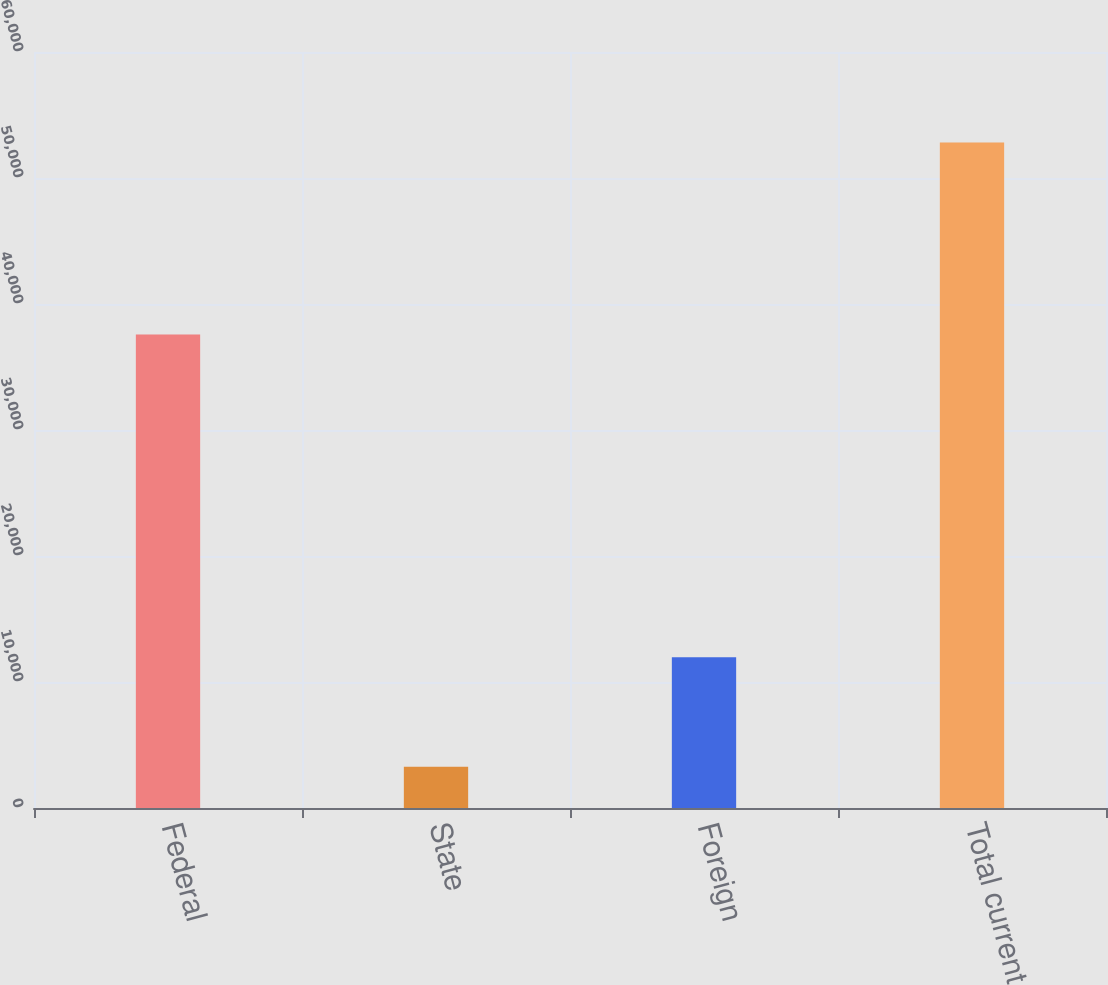Convert chart. <chart><loc_0><loc_0><loc_500><loc_500><bar_chart><fcel>Federal<fcel>State<fcel>Foreign<fcel>Total current<nl><fcel>37580<fcel>3268<fcel>11974<fcel>52822<nl></chart> 